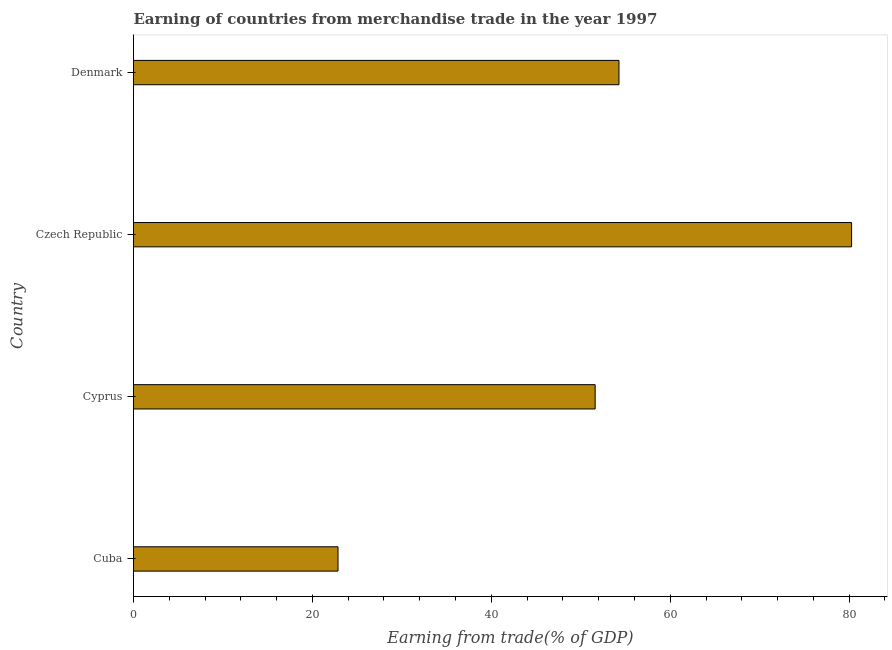Does the graph contain any zero values?
Give a very brief answer. No. Does the graph contain grids?
Ensure brevity in your answer.  No. What is the title of the graph?
Provide a short and direct response. Earning of countries from merchandise trade in the year 1997. What is the label or title of the X-axis?
Provide a short and direct response. Earning from trade(% of GDP). What is the earning from merchandise trade in Cuba?
Your answer should be very brief. 22.86. Across all countries, what is the maximum earning from merchandise trade?
Your answer should be very brief. 80.27. Across all countries, what is the minimum earning from merchandise trade?
Provide a short and direct response. 22.86. In which country was the earning from merchandise trade maximum?
Give a very brief answer. Czech Republic. In which country was the earning from merchandise trade minimum?
Your answer should be very brief. Cuba. What is the sum of the earning from merchandise trade?
Offer a terse response. 209.01. What is the difference between the earning from merchandise trade in Czech Republic and Denmark?
Offer a terse response. 26. What is the average earning from merchandise trade per country?
Provide a short and direct response. 52.25. What is the median earning from merchandise trade?
Your answer should be compact. 52.94. What is the ratio of the earning from merchandise trade in Cuba to that in Denmark?
Offer a terse response. 0.42. What is the difference between the highest and the second highest earning from merchandise trade?
Give a very brief answer. 26. Is the sum of the earning from merchandise trade in Cuba and Czech Republic greater than the maximum earning from merchandise trade across all countries?
Make the answer very short. Yes. What is the difference between the highest and the lowest earning from merchandise trade?
Offer a very short reply. 57.41. How many bars are there?
Your response must be concise. 4. Are all the bars in the graph horizontal?
Your answer should be very brief. Yes. How many countries are there in the graph?
Offer a very short reply. 4. What is the Earning from trade(% of GDP) of Cuba?
Ensure brevity in your answer.  22.86. What is the Earning from trade(% of GDP) of Cyprus?
Ensure brevity in your answer.  51.61. What is the Earning from trade(% of GDP) of Czech Republic?
Provide a short and direct response. 80.27. What is the Earning from trade(% of GDP) in Denmark?
Your answer should be compact. 54.27. What is the difference between the Earning from trade(% of GDP) in Cuba and Cyprus?
Give a very brief answer. -28.75. What is the difference between the Earning from trade(% of GDP) in Cuba and Czech Republic?
Provide a short and direct response. -57.41. What is the difference between the Earning from trade(% of GDP) in Cuba and Denmark?
Your response must be concise. -31.41. What is the difference between the Earning from trade(% of GDP) in Cyprus and Czech Republic?
Offer a very short reply. -28.67. What is the difference between the Earning from trade(% of GDP) in Cyprus and Denmark?
Offer a terse response. -2.66. What is the difference between the Earning from trade(% of GDP) in Czech Republic and Denmark?
Offer a terse response. 26. What is the ratio of the Earning from trade(% of GDP) in Cuba to that in Cyprus?
Provide a short and direct response. 0.44. What is the ratio of the Earning from trade(% of GDP) in Cuba to that in Czech Republic?
Give a very brief answer. 0.28. What is the ratio of the Earning from trade(% of GDP) in Cuba to that in Denmark?
Your answer should be compact. 0.42. What is the ratio of the Earning from trade(% of GDP) in Cyprus to that in Czech Republic?
Provide a succinct answer. 0.64. What is the ratio of the Earning from trade(% of GDP) in Cyprus to that in Denmark?
Provide a succinct answer. 0.95. What is the ratio of the Earning from trade(% of GDP) in Czech Republic to that in Denmark?
Your response must be concise. 1.48. 